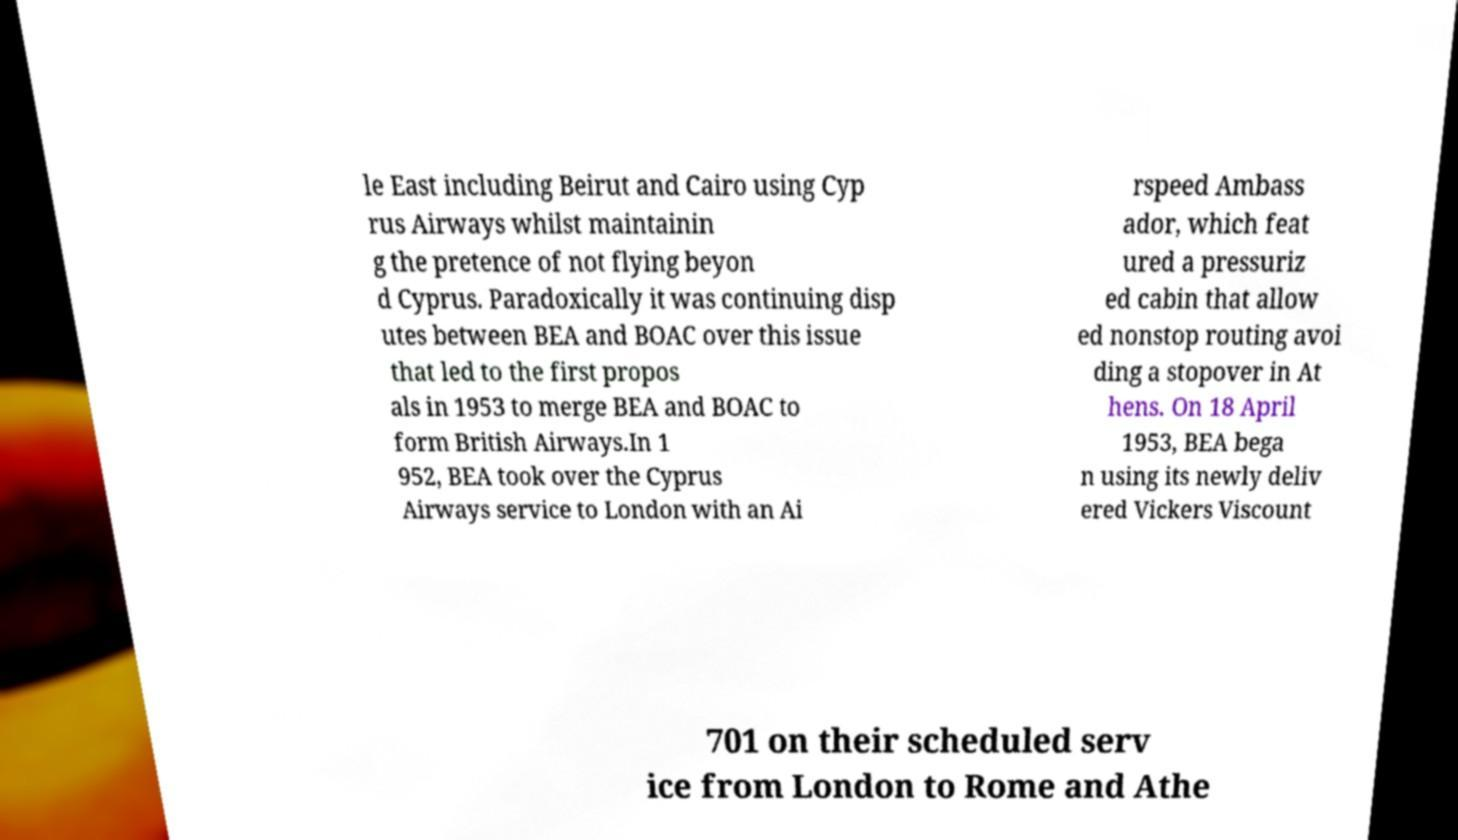There's text embedded in this image that I need extracted. Can you transcribe it verbatim? le East including Beirut and Cairo using Cyp rus Airways whilst maintainin g the pretence of not flying beyon d Cyprus. Paradoxically it was continuing disp utes between BEA and BOAC over this issue that led to the first propos als in 1953 to merge BEA and BOAC to form British Airways.In 1 952, BEA took over the Cyprus Airways service to London with an Ai rspeed Ambass ador, which feat ured a pressuriz ed cabin that allow ed nonstop routing avoi ding a stopover in At hens. On 18 April 1953, BEA bega n using its newly deliv ered Vickers Viscount 701 on their scheduled serv ice from London to Rome and Athe 